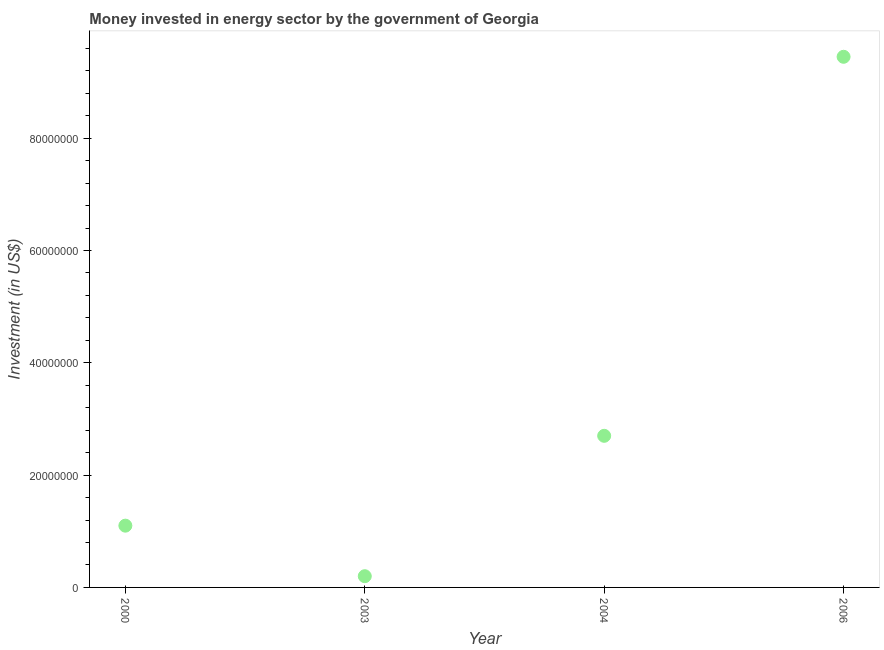What is the investment in energy in 2003?
Make the answer very short. 2.00e+06. Across all years, what is the maximum investment in energy?
Make the answer very short. 9.45e+07. Across all years, what is the minimum investment in energy?
Your response must be concise. 2.00e+06. In which year was the investment in energy maximum?
Keep it short and to the point. 2006. What is the sum of the investment in energy?
Provide a succinct answer. 1.34e+08. What is the difference between the investment in energy in 2003 and 2006?
Your response must be concise. -9.25e+07. What is the average investment in energy per year?
Offer a terse response. 3.36e+07. What is the median investment in energy?
Your response must be concise. 1.90e+07. In how many years, is the investment in energy greater than 84000000 US$?
Your answer should be very brief. 1. Do a majority of the years between 2000 and 2006 (inclusive) have investment in energy greater than 48000000 US$?
Ensure brevity in your answer.  No. What is the ratio of the investment in energy in 2003 to that in 2006?
Your answer should be very brief. 0.02. Is the investment in energy in 2003 less than that in 2004?
Your answer should be very brief. Yes. What is the difference between the highest and the second highest investment in energy?
Provide a succinct answer. 6.75e+07. Is the sum of the investment in energy in 2000 and 2004 greater than the maximum investment in energy across all years?
Provide a succinct answer. No. What is the difference between the highest and the lowest investment in energy?
Offer a very short reply. 9.25e+07. In how many years, is the investment in energy greater than the average investment in energy taken over all years?
Your answer should be very brief. 1. Does the investment in energy monotonically increase over the years?
Your answer should be very brief. No. How many dotlines are there?
Provide a short and direct response. 1. How many years are there in the graph?
Your answer should be very brief. 4. Does the graph contain any zero values?
Offer a terse response. No. Does the graph contain grids?
Make the answer very short. No. What is the title of the graph?
Give a very brief answer. Money invested in energy sector by the government of Georgia. What is the label or title of the Y-axis?
Provide a succinct answer. Investment (in US$). What is the Investment (in US$) in 2000?
Provide a succinct answer. 1.10e+07. What is the Investment (in US$) in 2004?
Keep it short and to the point. 2.70e+07. What is the Investment (in US$) in 2006?
Your response must be concise. 9.45e+07. What is the difference between the Investment (in US$) in 2000 and 2003?
Ensure brevity in your answer.  9.00e+06. What is the difference between the Investment (in US$) in 2000 and 2004?
Offer a very short reply. -1.60e+07. What is the difference between the Investment (in US$) in 2000 and 2006?
Offer a terse response. -8.35e+07. What is the difference between the Investment (in US$) in 2003 and 2004?
Offer a very short reply. -2.50e+07. What is the difference between the Investment (in US$) in 2003 and 2006?
Provide a succinct answer. -9.25e+07. What is the difference between the Investment (in US$) in 2004 and 2006?
Your answer should be compact. -6.75e+07. What is the ratio of the Investment (in US$) in 2000 to that in 2003?
Your answer should be compact. 5.5. What is the ratio of the Investment (in US$) in 2000 to that in 2004?
Your answer should be very brief. 0.41. What is the ratio of the Investment (in US$) in 2000 to that in 2006?
Your answer should be very brief. 0.12. What is the ratio of the Investment (in US$) in 2003 to that in 2004?
Your answer should be very brief. 0.07. What is the ratio of the Investment (in US$) in 2003 to that in 2006?
Your answer should be very brief. 0.02. What is the ratio of the Investment (in US$) in 2004 to that in 2006?
Your response must be concise. 0.29. 